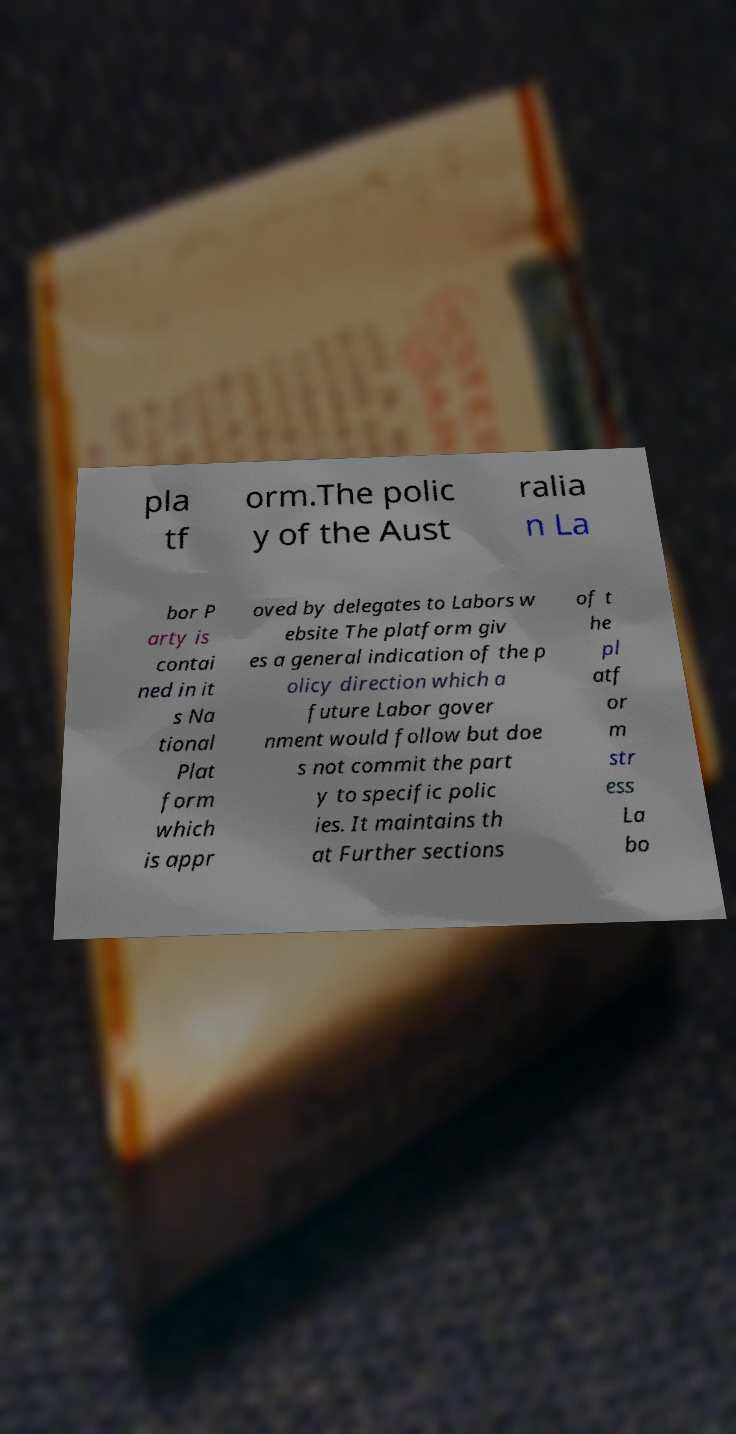For documentation purposes, I need the text within this image transcribed. Could you provide that? pla tf orm.The polic y of the Aust ralia n La bor P arty is contai ned in it s Na tional Plat form which is appr oved by delegates to Labors w ebsite The platform giv es a general indication of the p olicy direction which a future Labor gover nment would follow but doe s not commit the part y to specific polic ies. It maintains th at Further sections of t he pl atf or m str ess La bo 